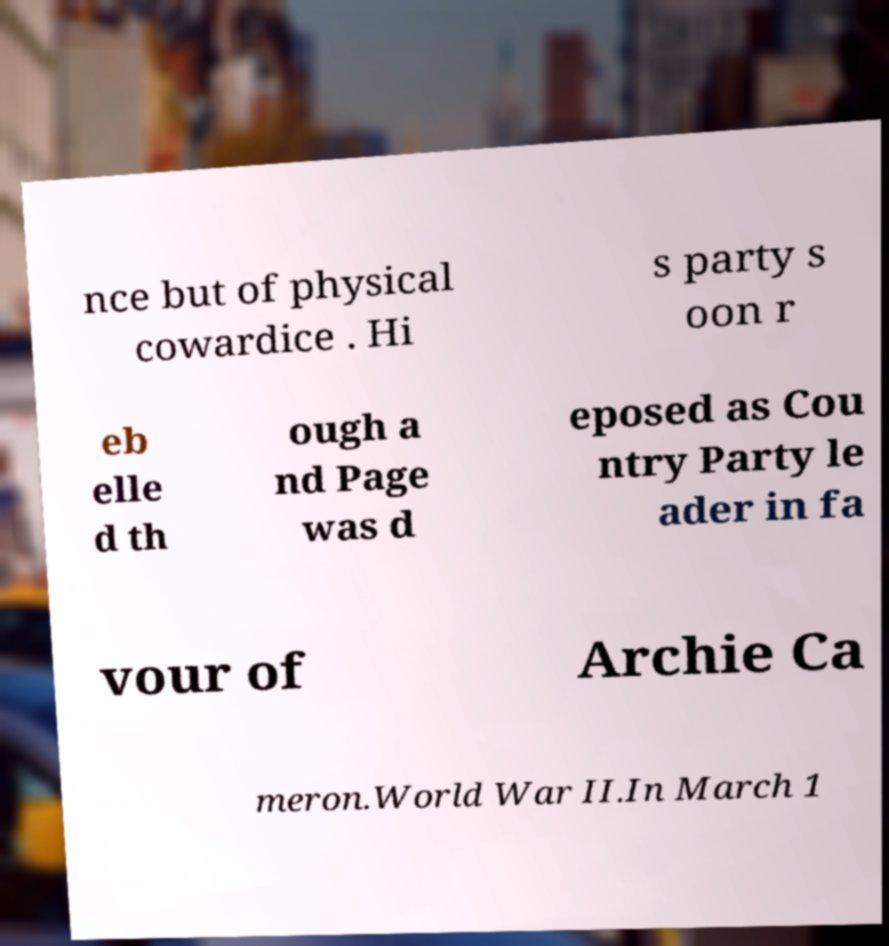Please identify and transcribe the text found in this image. nce but of physical cowardice . Hi s party s oon r eb elle d th ough a nd Page was d eposed as Cou ntry Party le ader in fa vour of Archie Ca meron.World War II.In March 1 